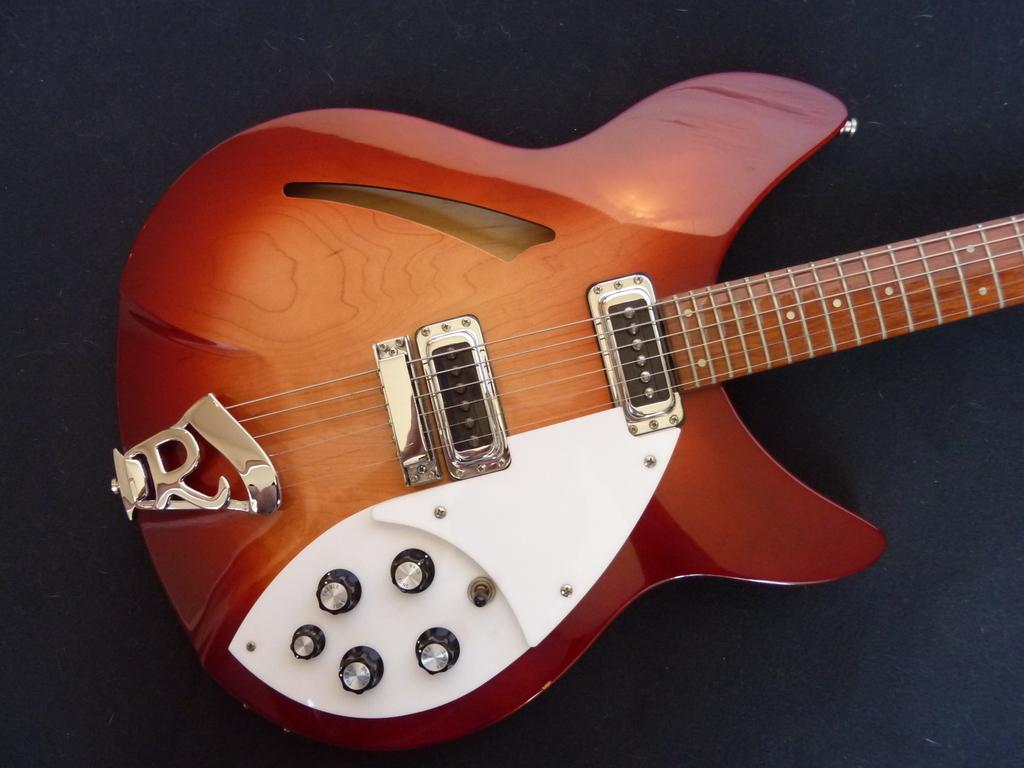What is the main object in the image? There is a guitar in the image. Where is the guitar located in the image? The guitar is in the center of the image. What color is the guitar? The guitar is brown in color. What direction is the fan blowing in the image? There is no fan present in the image. Is there a notebook on the guitar in the image? There is no notebook present in the image. 